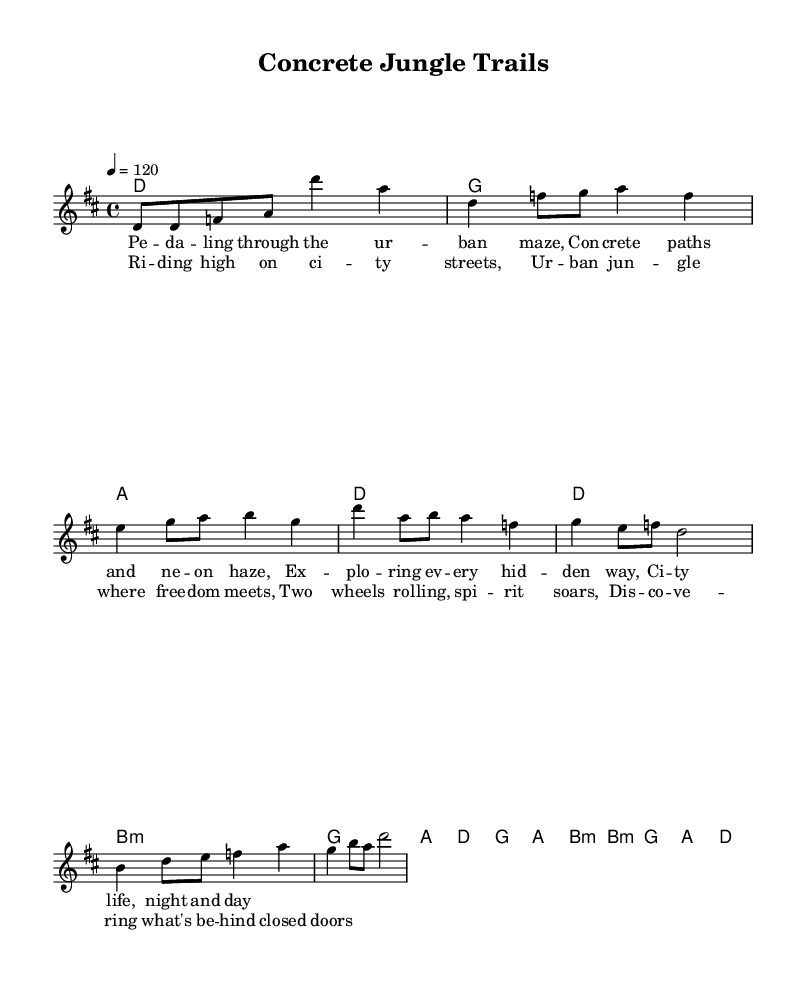What is the key signature of this music? The key signature is indicated at the beginning of the music sheet, showing two sharps. This corresponds to D major.
Answer: D major What is the time signature of this music? The time signature is located at the beginning of the sheet music next to the key signature. It is 4/4, indicating four beats per measure.
Answer: 4/4 What is the tempo marking of this music? The tempo marking is provided in the global section of the code, indicating that the piece should be played at a speed of quarter note = 120 beats per minute.
Answer: 120 How many measures are in the verse section? By examining the melody for the verse indicated in the code, we can see that there are four lines of lyrics, and each measure contains two beats. This totals to 8 measures in the verse section.
Answer: 8 What is the last chord of the chorus? The chorus is indicated in the harmonies section, and the final chord noted in the section is D major. We can verify this by looking at the structure and the sequence of chords.
Answer: D What is the lyrical theme of the song? Analyzing the lyrics provided in the verse and chorus, they focus on urban exploration, city life themes, and the freedom associated with cycling through the city. This indicates a narrative around adventure and discovery.
Answer: Urban exploration What is the structure of the song? The structure can be inferred from the sections defined in the code: intro, verse, chorus, and bridge. This reveals the overall arrangement of the piece.
Answer: Intro, Verse, Chorus, Bridge 